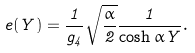<formula> <loc_0><loc_0><loc_500><loc_500>\ e ( Y ) = \frac { 1 } { g _ { 4 } } \sqrt { \frac { \alpha } { 2 } } \frac { 1 } { \cosh \alpha Y } .</formula> 